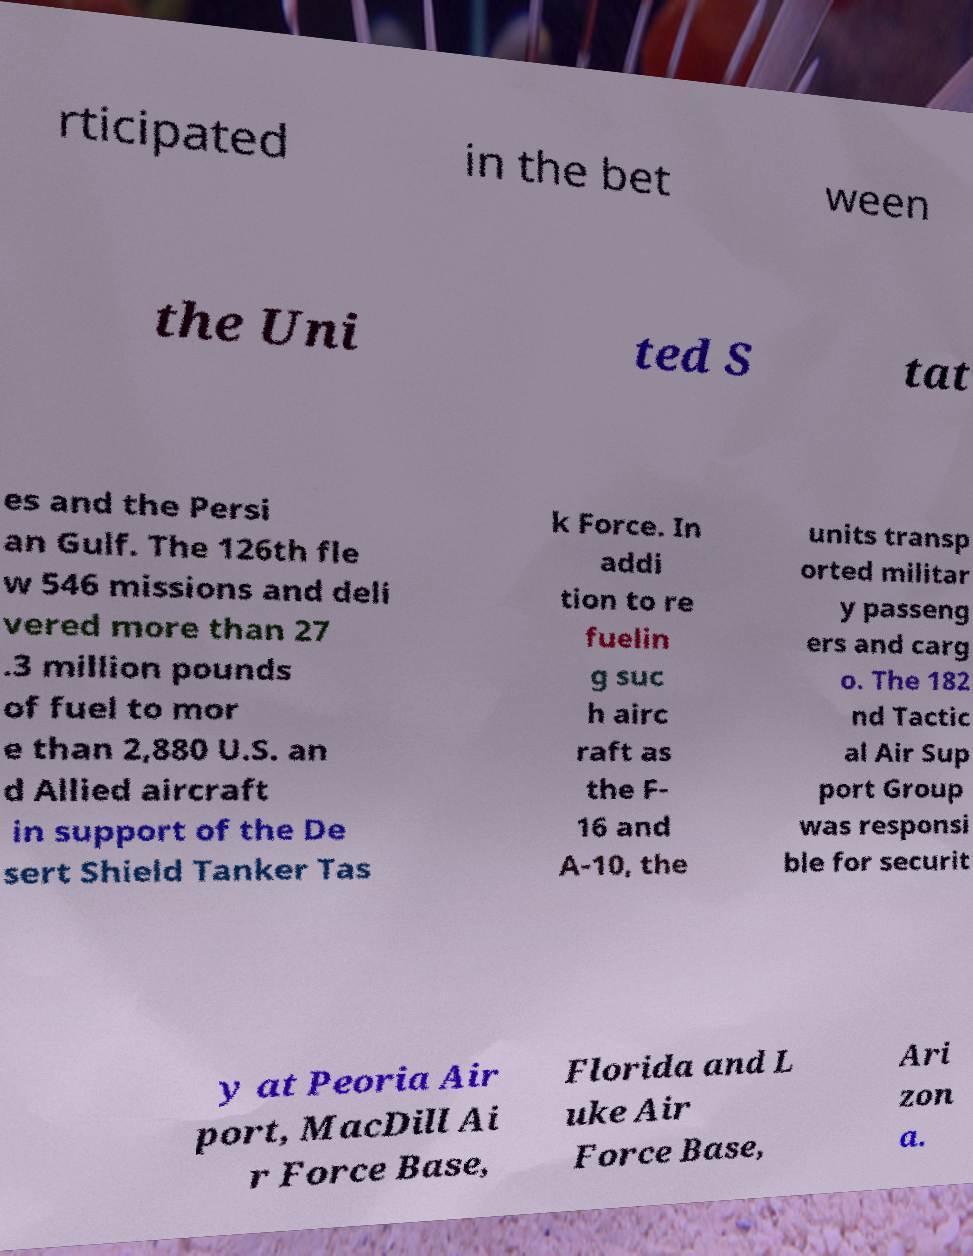Please read and relay the text visible in this image. What does it say? rticipated in the bet ween the Uni ted S tat es and the Persi an Gulf. The 126th fle w 546 missions and deli vered more than 27 .3 million pounds of fuel to mor e than 2,880 U.S. an d Allied aircraft in support of the De sert Shield Tanker Tas k Force. In addi tion to re fuelin g suc h airc raft as the F- 16 and A-10, the units transp orted militar y passeng ers and carg o. The 182 nd Tactic al Air Sup port Group was responsi ble for securit y at Peoria Air port, MacDill Ai r Force Base, Florida and L uke Air Force Base, Ari zon a. 